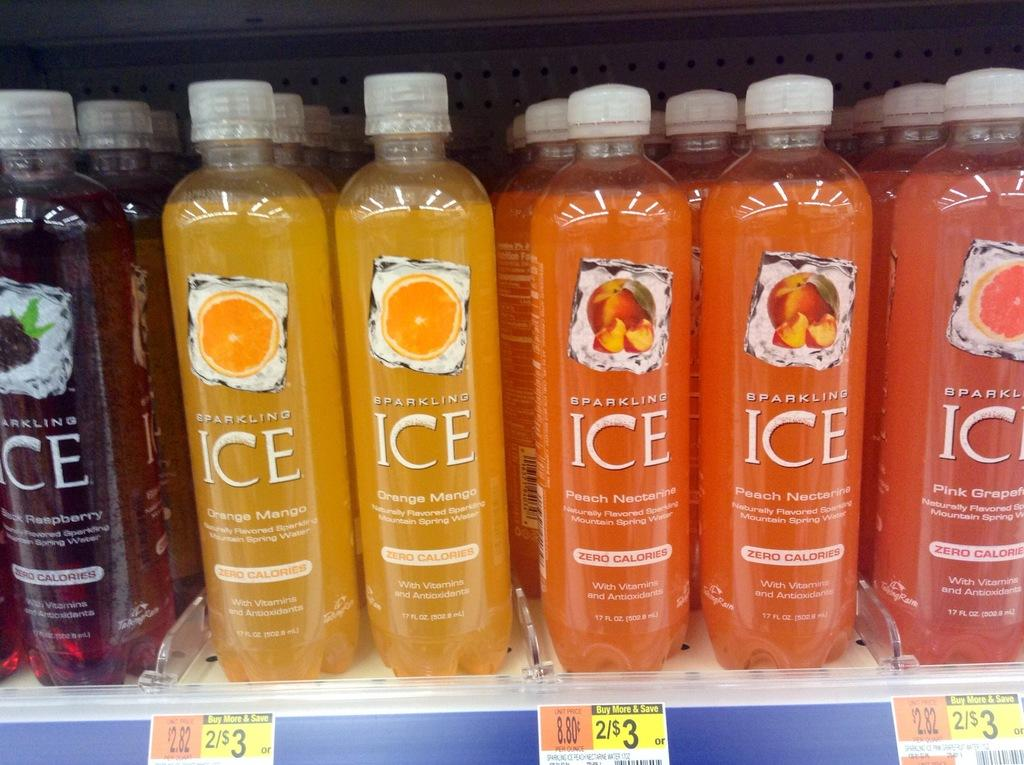<image>
Give a short and clear explanation of the subsequent image. Bottles of Sparkling Ice on sale 2 for 3 